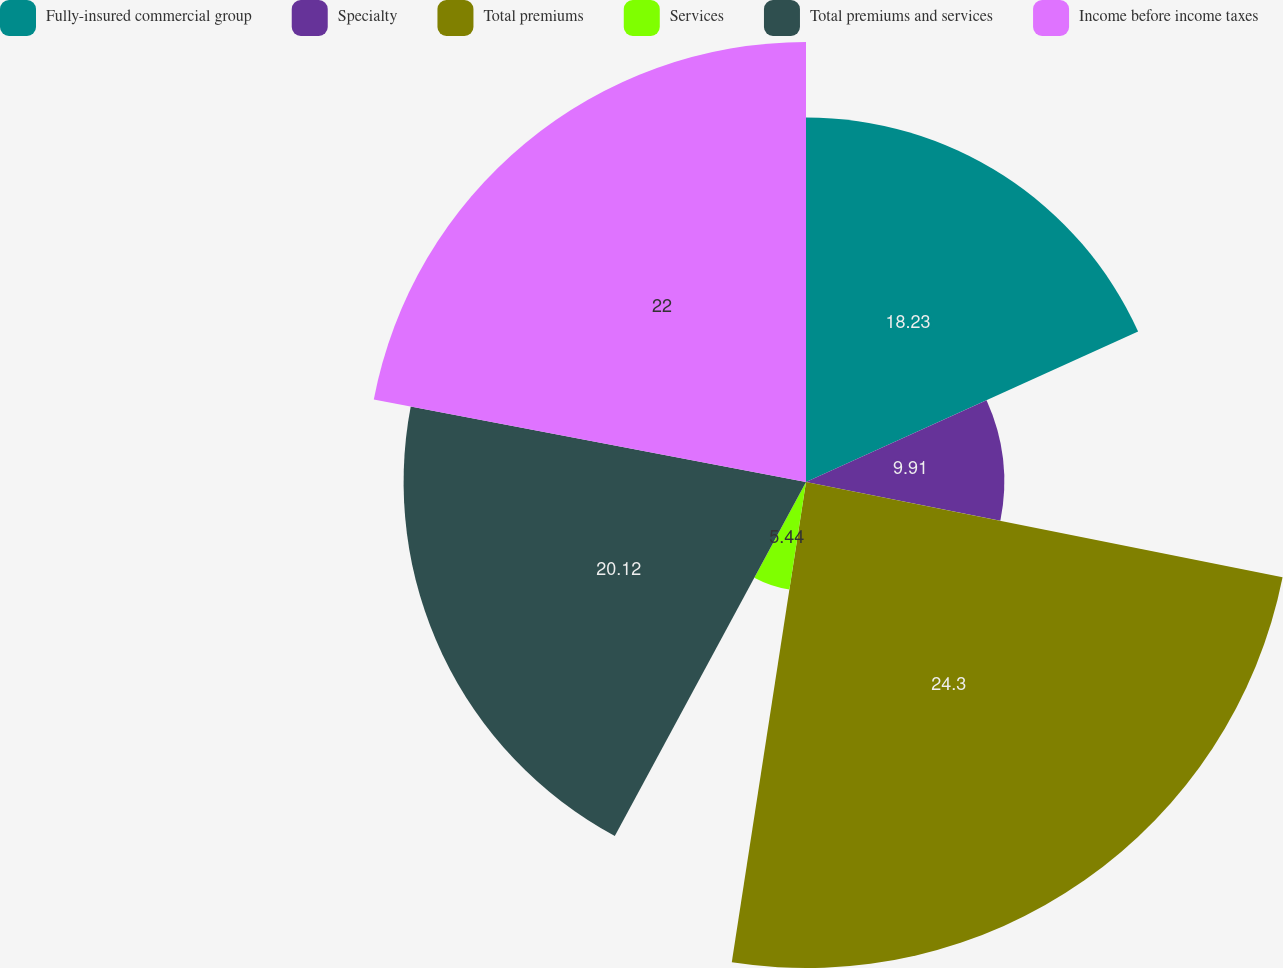Convert chart to OTSL. <chart><loc_0><loc_0><loc_500><loc_500><pie_chart><fcel>Fully-insured commercial group<fcel>Specialty<fcel>Total premiums<fcel>Services<fcel>Total premiums and services<fcel>Income before income taxes<nl><fcel>18.23%<fcel>9.91%<fcel>24.3%<fcel>5.44%<fcel>20.12%<fcel>22.0%<nl></chart> 